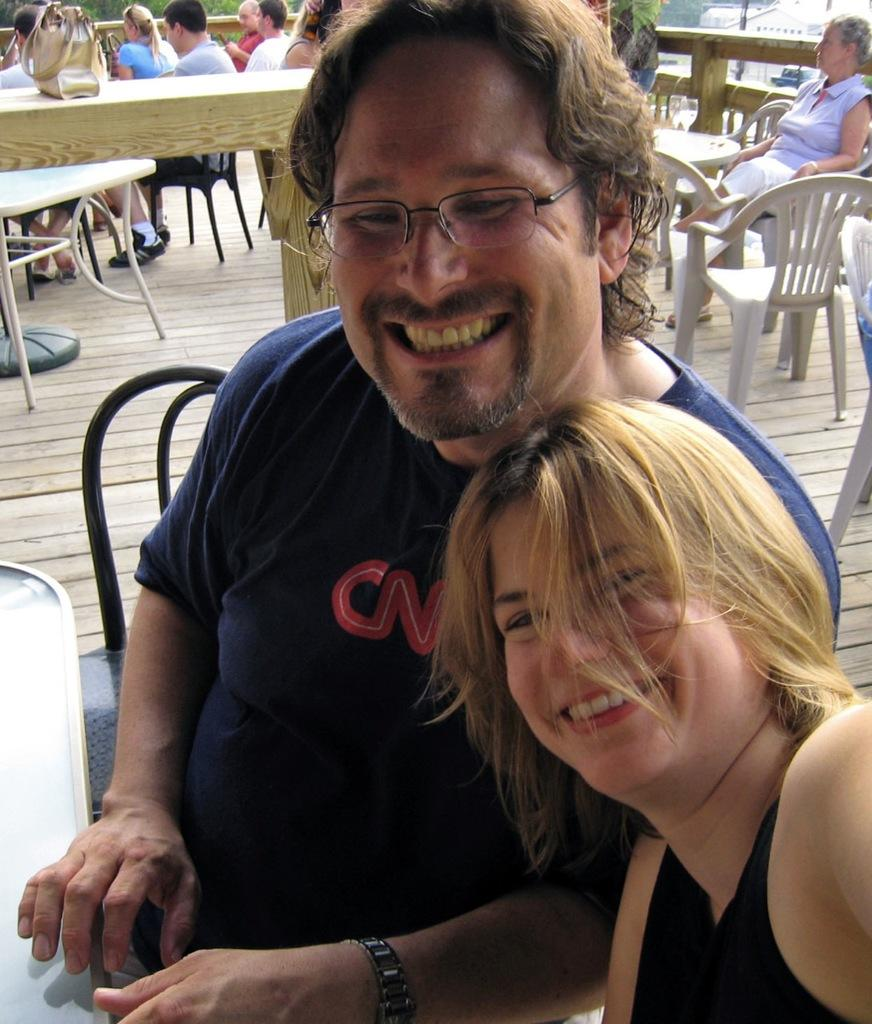What are the persons in the image doing? The persons in the image are sitting on chairs in front of a table. What object can be seen on the table? There is a handbag on the table. What type of natural environment is visible in the image? Trees are visible in the image. What type of man-made structure is present in the image? There is a building in the image. What type of pie is being served on the stage in the image? There is no pie or stage present in the image. Can you describe the texture of the handbag in the image? The provided facts do not include information about the texture of the handbag, so it cannot be described. 